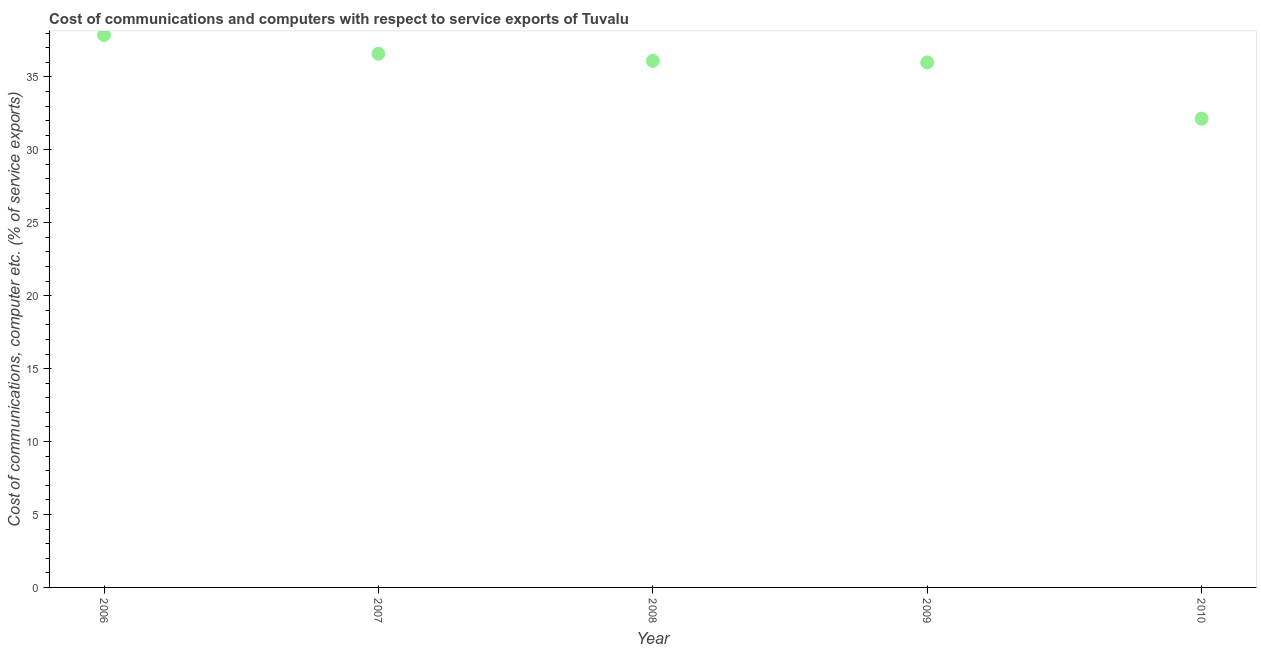What is the cost of communications and computer in 2010?
Offer a very short reply. 32.13. Across all years, what is the maximum cost of communications and computer?
Make the answer very short. 37.87. Across all years, what is the minimum cost of communications and computer?
Provide a short and direct response. 32.13. In which year was the cost of communications and computer maximum?
Provide a short and direct response. 2006. In which year was the cost of communications and computer minimum?
Your answer should be compact. 2010. What is the sum of the cost of communications and computer?
Offer a terse response. 178.67. What is the difference between the cost of communications and computer in 2008 and 2010?
Your response must be concise. 3.96. What is the average cost of communications and computer per year?
Keep it short and to the point. 35.73. What is the median cost of communications and computer?
Provide a succinct answer. 36.1. Do a majority of the years between 2009 and 2006 (inclusive) have cost of communications and computer greater than 18 %?
Your answer should be very brief. Yes. What is the ratio of the cost of communications and computer in 2008 to that in 2009?
Provide a succinct answer. 1. Is the cost of communications and computer in 2008 less than that in 2010?
Offer a very short reply. No. What is the difference between the highest and the second highest cost of communications and computer?
Your answer should be very brief. 1.29. What is the difference between the highest and the lowest cost of communications and computer?
Offer a very short reply. 5.73. In how many years, is the cost of communications and computer greater than the average cost of communications and computer taken over all years?
Ensure brevity in your answer.  4. Does the cost of communications and computer monotonically increase over the years?
Make the answer very short. No. Does the graph contain any zero values?
Keep it short and to the point. No. Does the graph contain grids?
Offer a very short reply. No. What is the title of the graph?
Provide a succinct answer. Cost of communications and computers with respect to service exports of Tuvalu. What is the label or title of the X-axis?
Your answer should be very brief. Year. What is the label or title of the Y-axis?
Ensure brevity in your answer.  Cost of communications, computer etc. (% of service exports). What is the Cost of communications, computer etc. (% of service exports) in 2006?
Make the answer very short. 37.87. What is the Cost of communications, computer etc. (% of service exports) in 2007?
Make the answer very short. 36.58. What is the Cost of communications, computer etc. (% of service exports) in 2008?
Provide a succinct answer. 36.1. What is the Cost of communications, computer etc. (% of service exports) in 2009?
Give a very brief answer. 35.99. What is the Cost of communications, computer etc. (% of service exports) in 2010?
Offer a terse response. 32.13. What is the difference between the Cost of communications, computer etc. (% of service exports) in 2006 and 2007?
Ensure brevity in your answer.  1.29. What is the difference between the Cost of communications, computer etc. (% of service exports) in 2006 and 2008?
Provide a short and direct response. 1.77. What is the difference between the Cost of communications, computer etc. (% of service exports) in 2006 and 2009?
Offer a terse response. 1.88. What is the difference between the Cost of communications, computer etc. (% of service exports) in 2006 and 2010?
Give a very brief answer. 5.73. What is the difference between the Cost of communications, computer etc. (% of service exports) in 2007 and 2008?
Give a very brief answer. 0.49. What is the difference between the Cost of communications, computer etc. (% of service exports) in 2007 and 2009?
Provide a short and direct response. 0.6. What is the difference between the Cost of communications, computer etc. (% of service exports) in 2007 and 2010?
Your answer should be very brief. 4.45. What is the difference between the Cost of communications, computer etc. (% of service exports) in 2008 and 2009?
Your answer should be very brief. 0.11. What is the difference between the Cost of communications, computer etc. (% of service exports) in 2008 and 2010?
Your answer should be very brief. 3.96. What is the difference between the Cost of communications, computer etc. (% of service exports) in 2009 and 2010?
Ensure brevity in your answer.  3.85. What is the ratio of the Cost of communications, computer etc. (% of service exports) in 2006 to that in 2007?
Offer a terse response. 1.03. What is the ratio of the Cost of communications, computer etc. (% of service exports) in 2006 to that in 2008?
Your answer should be very brief. 1.05. What is the ratio of the Cost of communications, computer etc. (% of service exports) in 2006 to that in 2009?
Offer a very short reply. 1.05. What is the ratio of the Cost of communications, computer etc. (% of service exports) in 2006 to that in 2010?
Your answer should be compact. 1.18. What is the ratio of the Cost of communications, computer etc. (% of service exports) in 2007 to that in 2009?
Offer a terse response. 1.02. What is the ratio of the Cost of communications, computer etc. (% of service exports) in 2007 to that in 2010?
Your response must be concise. 1.14. What is the ratio of the Cost of communications, computer etc. (% of service exports) in 2008 to that in 2009?
Offer a terse response. 1. What is the ratio of the Cost of communications, computer etc. (% of service exports) in 2008 to that in 2010?
Offer a very short reply. 1.12. What is the ratio of the Cost of communications, computer etc. (% of service exports) in 2009 to that in 2010?
Your response must be concise. 1.12. 